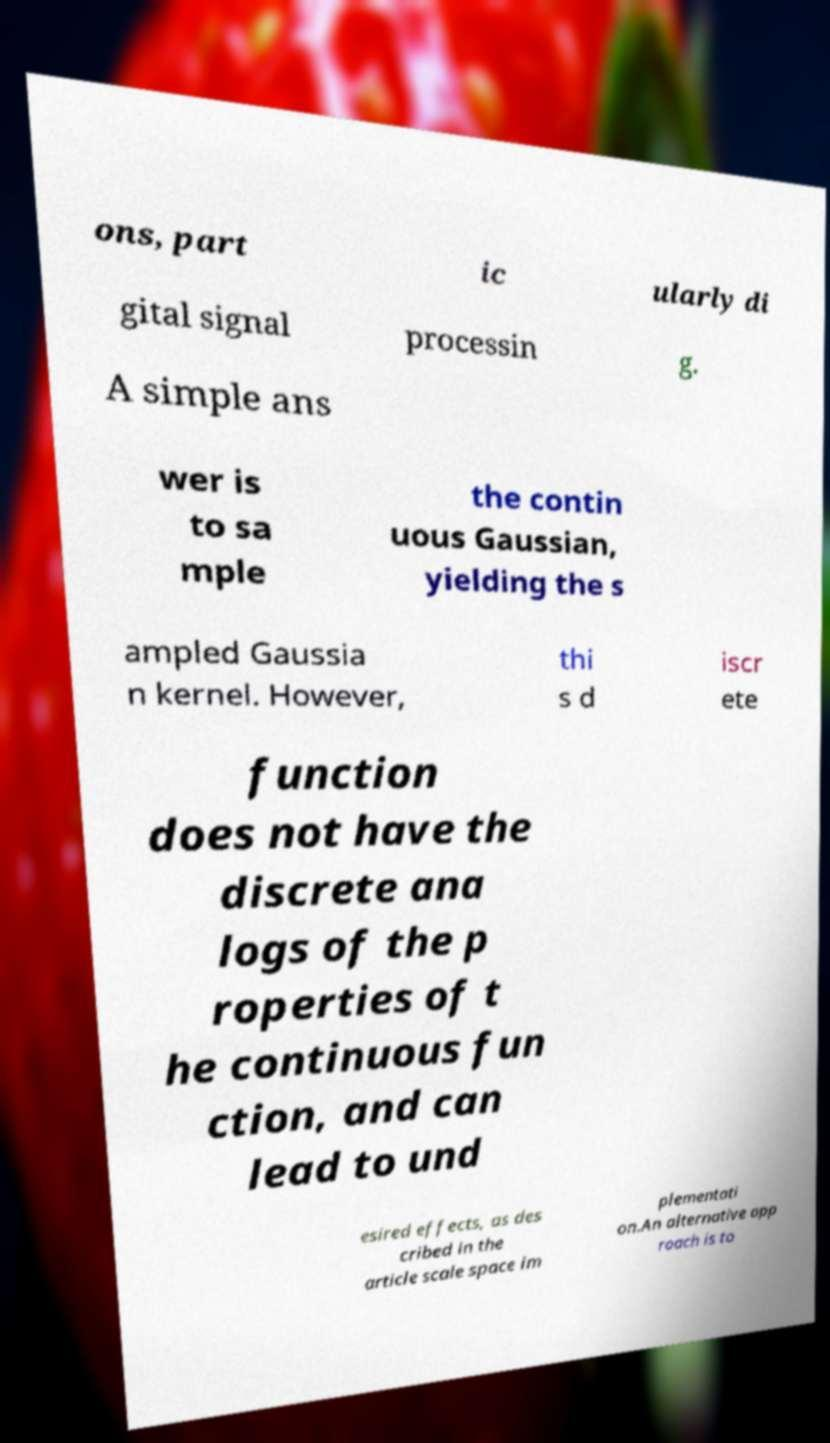Please identify and transcribe the text found in this image. ons, part ic ularly di gital signal processin g. A simple ans wer is to sa mple the contin uous Gaussian, yielding the s ampled Gaussia n kernel. However, thi s d iscr ete function does not have the discrete ana logs of the p roperties of t he continuous fun ction, and can lead to und esired effects, as des cribed in the article scale space im plementati on.An alternative app roach is to 